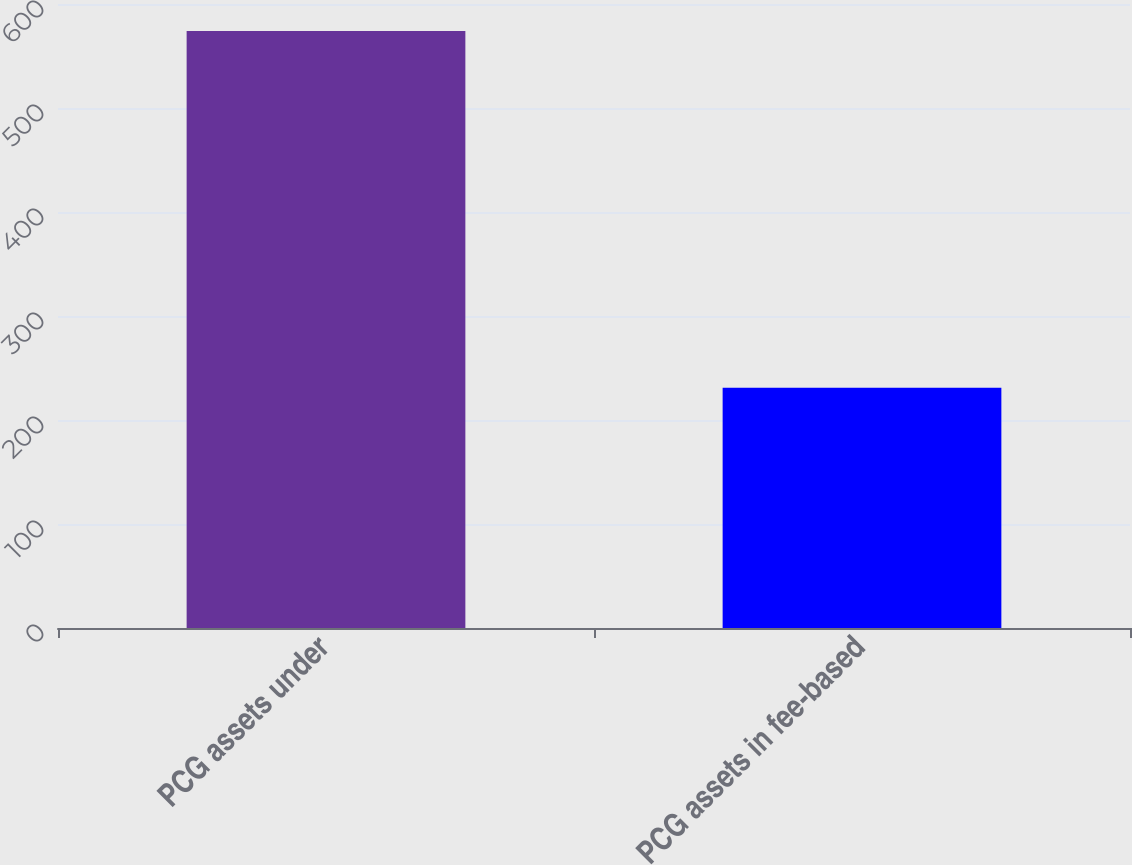<chart> <loc_0><loc_0><loc_500><loc_500><bar_chart><fcel>PCG assets under<fcel>PCG assets in fee-based<nl><fcel>574.1<fcel>231<nl></chart> 